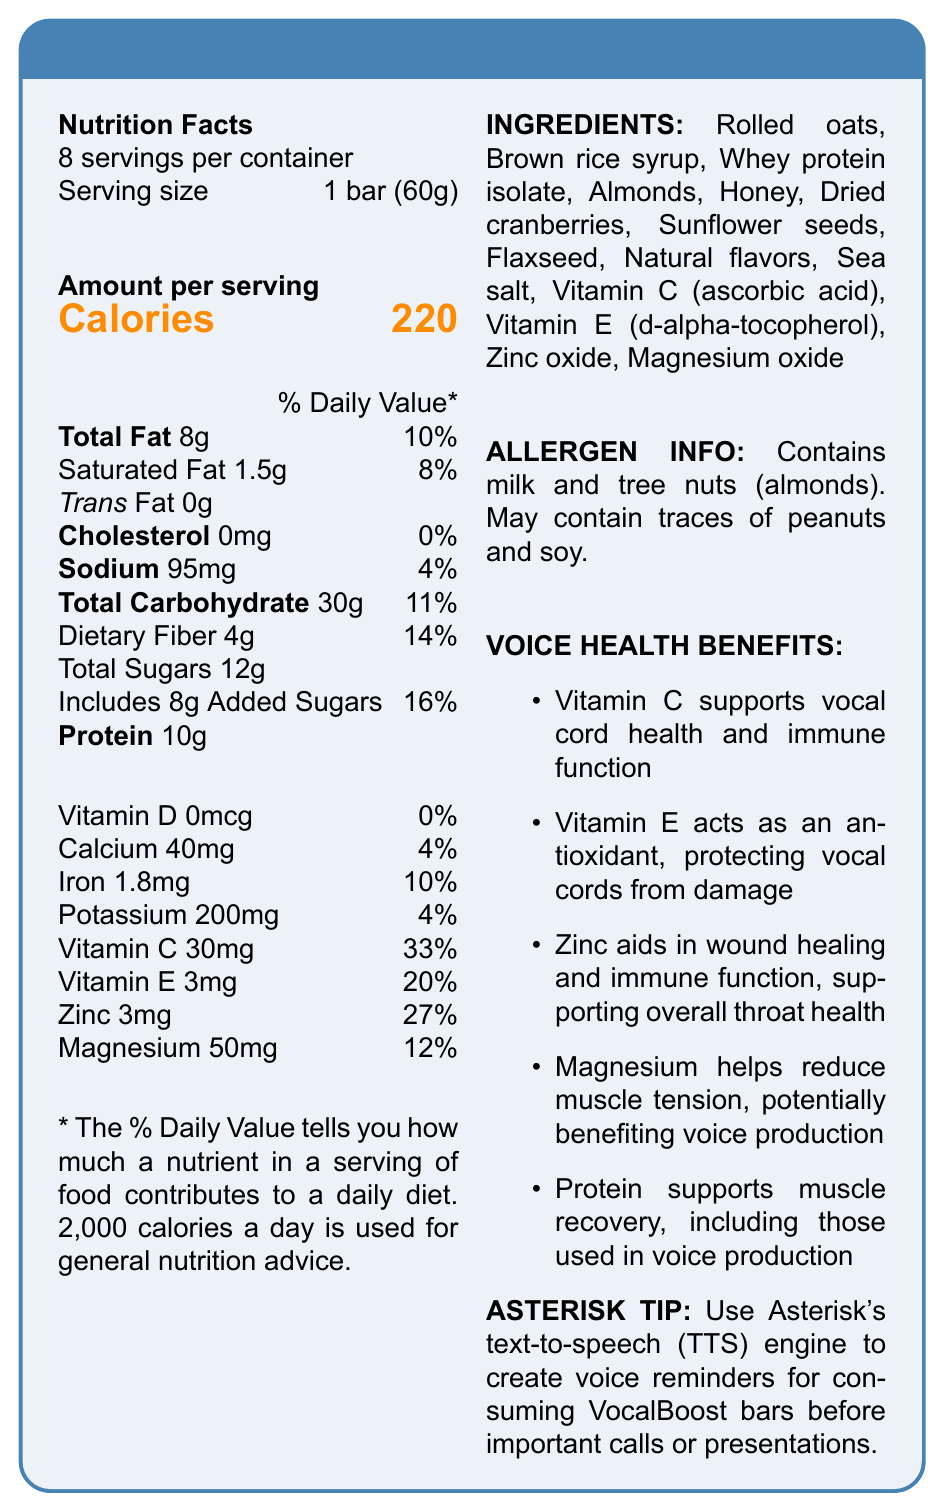What is the serving size of the VocalBoost Energy Bar? The serving size is clearly stated under the Nutrition Facts section on the left column.
Answer: 1 bar (60g) How many servings are there per container of VocalBoost Energy Bar? The document mentions "8 servings per container" in the Nutrition Facts section.
Answer: 8 How many calories are there in one serving of the VocalBoost Energy Bar? Under the Nutrition Facts section, it states "Calories 220" in large text.
Answer: 220 Which vitamins contribute to the voice health benefits of the VocalBoost Energy Bar? The Voice Health Benefits section lists both Vitamin C and Vitamin E as beneficial for vocal health.
Answer: Vitamin C, Vitamin E What is the amount of protein per serving? The Nutrition Facts section lists "Protein 10g".
Answer: 10g Which ingredient is an allergen mentioned in the document? The Allergen Info section states that the product contains milk and tree nuts (almonds).
Answer: Almonds (tree nuts) How much dietary fiber is in one serving, and what is its daily value percentage? The Nutrition Facts section states "Dietary Fiber 4g" with a daily value percentage of 14%.
Answer: 4g, 14% Does the document mention the presence of any trans fat? The Nutrition Facts section indicates "Trans Fat 0g".
Answer: No What minerals are included in the VocalBoost Energy Bar? The Nutrition Facts section lists these minerals with their corresponding amounts and daily value percentages.
Answer: Calcium, Iron, Potassium, Zinc, Magnesium What is the main idea of this document? The document comprehensively covers various aspects of the VocalBoost Energy Bar, including its nutritional value, ingredients, potential allergens, benefits for vocal health, and practical tips for using it in conjunction with Asterisk.
Answer: It provides the Nutrition Facts, ingredients, allergen information, voice health benefits, and Asterisk integration tips for the VocalBoost Energy Bar. How much vitamin D does the VocalBoost Energy Bar contain per serving? The Nutrition Facts section lists "Vitamin D 0mcg" with a daily value percentage of 0%.
Answer: 0mcg What are the two major benefits of magnesium mentioned in the document? The Voice Health Benefits section mentions magnesium's role in reducing muscle tension and its potential benefits for voice production.
Answer: Reduces muscle tension and potentially benefits voice production Which of the following minerals has the highest daily value percentage in the VocalBoost Energy Bar?
A. Calcium
B. Iron
C. Zinc
D. Magnesium The Nutrition Facts section shows Zinc with a daily value percentage of 27%, which is higher than the percentages for Calcium (4%), Iron (10%), and Magnesium (12%).
Answer: C Which ingredient is not explicitly listed in the Nutrition Facts section?
A. Rolled oats
B. Sea salt
C. Natural flavors
D. Vitamin B12 Vitamin B12 is not listed among the ingredients in the Nutrition Facts section or elsewhere in the document.
Answer: D True or False: The VocalBoost Energy Bar contains honey. The ingredient list includes honey.
Answer: True Which ingredients in the VocalBoost Energy Bar provide potential allergens? A. Milk B. Almonds C. Peanuts D. Soy The Allergen Info section mentions milk and almonds (tree nuts) as the ingredients that provide potential allergens. Peanuts and soy may contain traces but are not explicitly stated as primary allergens.
Answer: A, B How should one use VocalBoost Energy Bars in conjunction with Asterisk? The Asterisk Tip section suggests using Asterisk's TTS engine to create these reminders.
Answer: By creating voice reminders using Asterisk’s text-to-speech (TTS) engine to consume the bars before important calls or presentations Does the document provide information about the environmental impact of the VocalBoost Energy Bar's packaging? The document does not mention anything about the environmental impact of the packaging.
Answer: Not enough information 